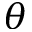Convert formula to latex. <formula><loc_0><loc_0><loc_500><loc_500>\theta</formula> 